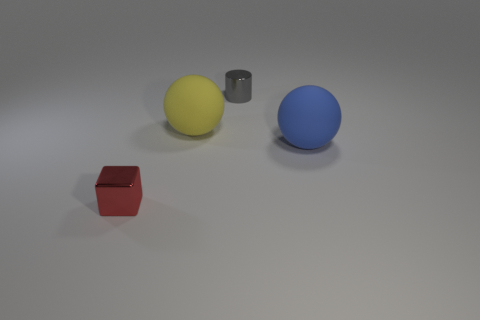How many purple objects are shiny blocks or rubber things?
Make the answer very short. 0. What number of other objects are the same shape as the tiny gray metal thing?
Your answer should be very brief. 0. What is the shape of the thing that is both in front of the big yellow object and to the left of the gray metallic object?
Provide a short and direct response. Cube. Are there any large balls behind the blue sphere?
Provide a short and direct response. Yes. What is the size of the other thing that is the same shape as the big blue thing?
Keep it short and to the point. Large. Is the shape of the big blue matte object the same as the large yellow rubber thing?
Offer a terse response. Yes. There is a matte object that is left of the tiny shiny thing behind the small cube; what size is it?
Make the answer very short. Large. What color is the other large thing that is the same shape as the large yellow object?
Offer a terse response. Blue. How big is the blue matte ball?
Give a very brief answer. Large. Does the red object have the same size as the yellow matte object?
Offer a very short reply. No. 